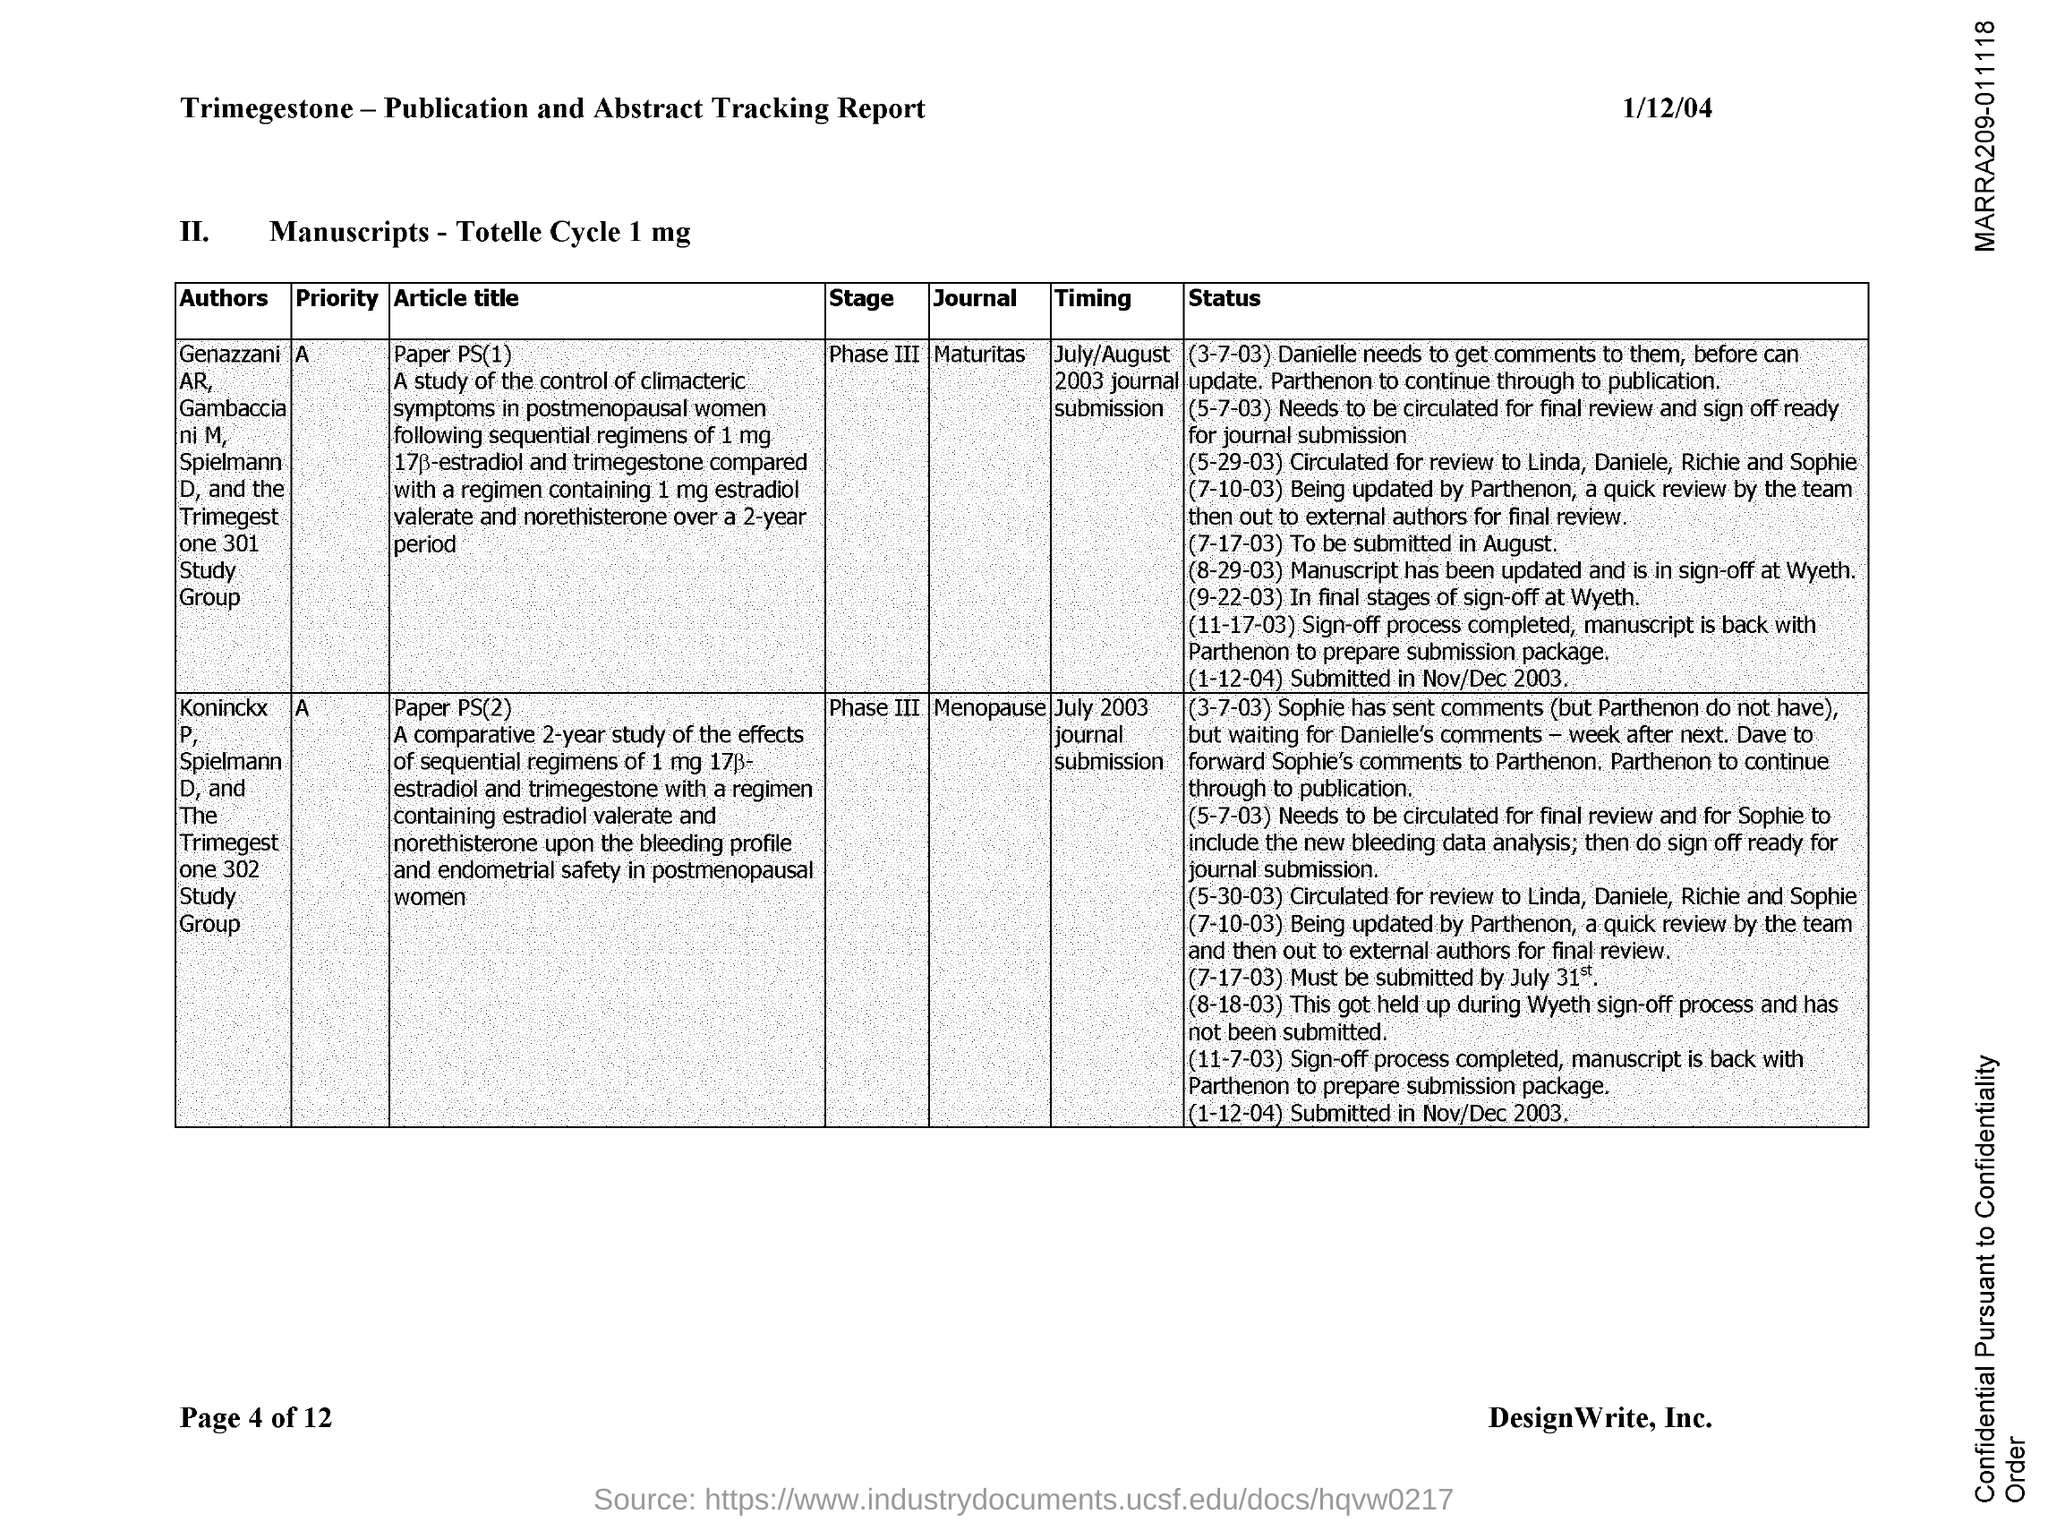What is the date on the document?
Offer a very short reply. 1/12/04. 